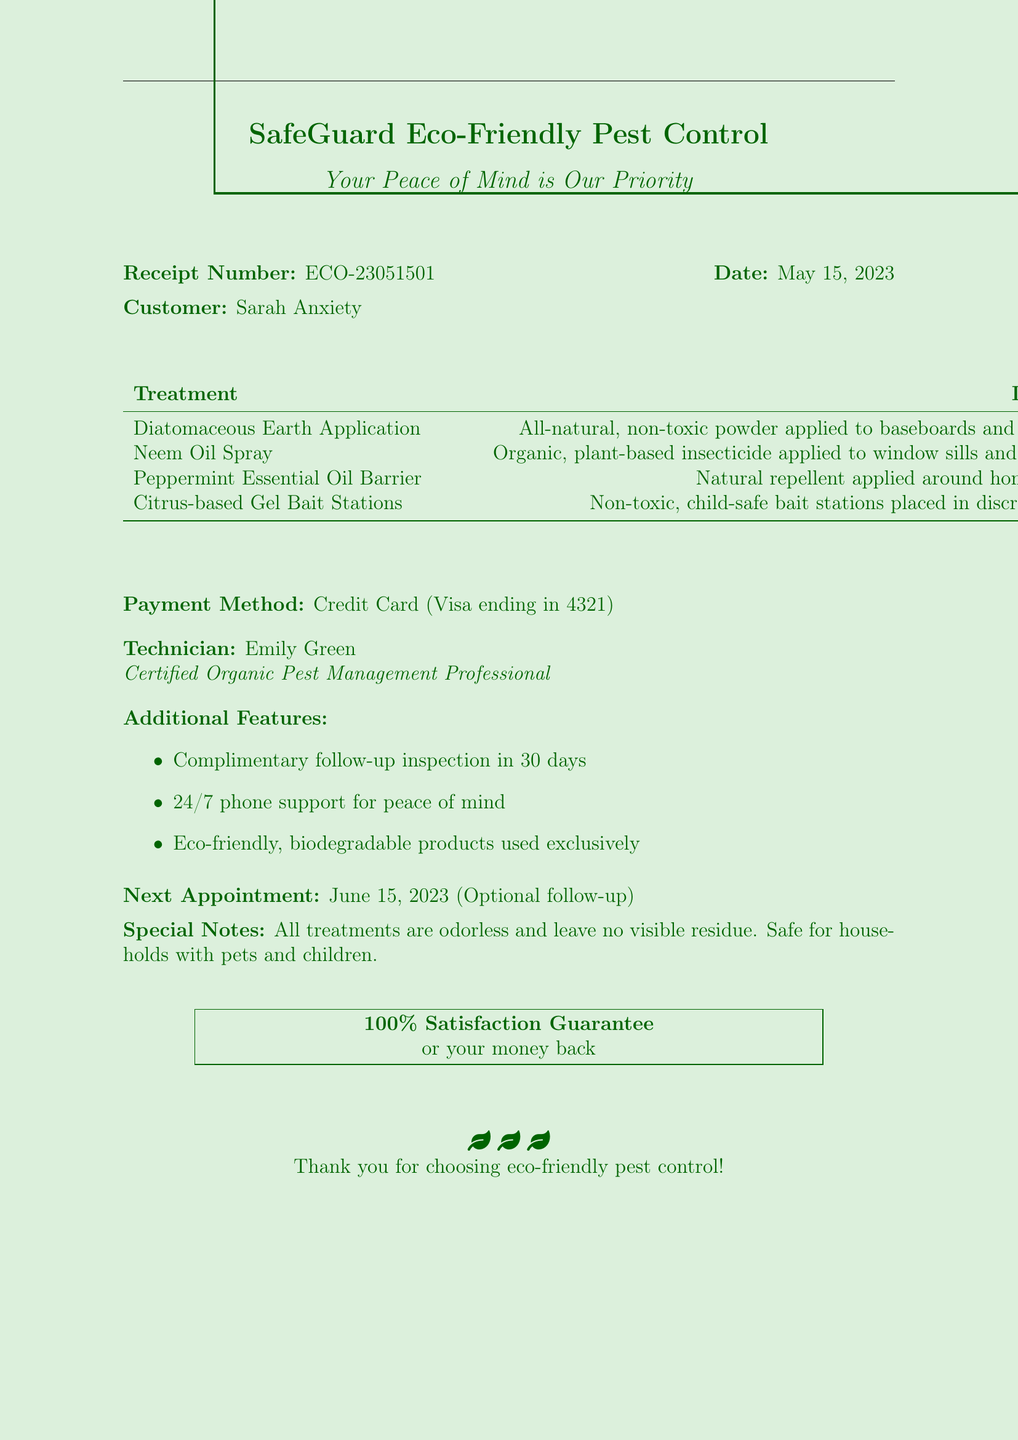what is the company name? The company name is the first detail presented in the document.
Answer: SafeGuard Eco-Friendly Pest Control who is the customer? The customer's name is clearly stated on the receipt.
Answer: Sarah Anxiety what date was the service provided? The date of service is mentioned next to the receipt number.
Answer: May 15, 2023 how many services are listed? The document includes a list of services provided, which can be counted.
Answer: 4 what is the total amount charged? The total amount is specified in the table of services at the end of the document.
Answer: $294.96 what type of guarantee is provided? The document mentions a specific type of guarantee related to customer satisfaction.
Answer: 100% satisfaction guarantee what is the next appointment date? The next appointment is indicated in the special notes section of the document.
Answer: June 15, 2023 what treatment is safe for households with pets and children? The special notes highlight that all treatments are safe for the specified populations.
Answer: All treatments who performed the service? The receipt includes the name of the technician who provided the service.
Answer: Emily Green what method of payment was used? The method of payment is explicitly stated in the receipt.
Answer: Credit Card (Visa ending in 4321) 